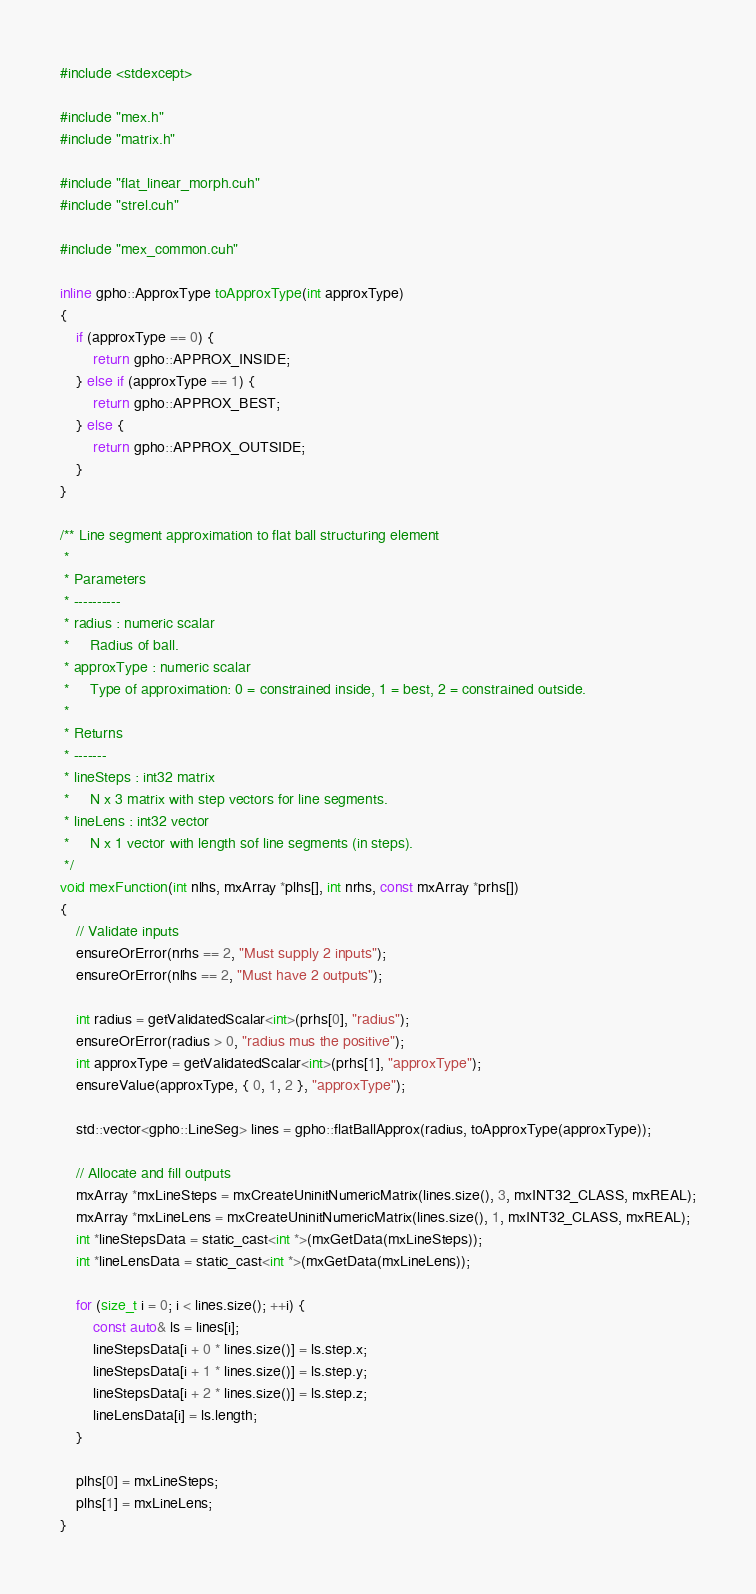<code> <loc_0><loc_0><loc_500><loc_500><_Cuda_>#include <stdexcept>

#include "mex.h"
#include "matrix.h"

#include "flat_linear_morph.cuh"
#include "strel.cuh"

#include "mex_common.cuh"

inline gpho::ApproxType toApproxType(int approxType)
{
    if (approxType == 0) {
        return gpho::APPROX_INSIDE;
    } else if (approxType == 1) {
        return gpho::APPROX_BEST;
    } else {
        return gpho::APPROX_OUTSIDE;
    }
}

/** Line segment approximation to flat ball structuring element
 *
 * Parameters
 * ----------
 * radius : numeric scalar
 *     Radius of ball.
 * approxType : numeric scalar
 *     Type of approximation: 0 = constrained inside, 1 = best, 2 = constrained outside.
 *
 * Returns
 * -------
 * lineSteps : int32 matrix
 *     N x 3 matrix with step vectors for line segments.
 * lineLens : int32 vector
 *     N x 1 vector with length sof line segments (in steps).
 */
void mexFunction(int nlhs, mxArray *plhs[], int nrhs, const mxArray *prhs[])
{
    // Validate inputs
    ensureOrError(nrhs == 2, "Must supply 2 inputs");
    ensureOrError(nlhs == 2, "Must have 2 outputs");

    int radius = getValidatedScalar<int>(prhs[0], "radius");
    ensureOrError(radius > 0, "radius mus the positive");
    int approxType = getValidatedScalar<int>(prhs[1], "approxType");
    ensureValue(approxType, { 0, 1, 2 }, "approxType");

    std::vector<gpho::LineSeg> lines = gpho::flatBallApprox(radius, toApproxType(approxType));

    // Allocate and fill outputs
    mxArray *mxLineSteps = mxCreateUninitNumericMatrix(lines.size(), 3, mxINT32_CLASS, mxREAL);
    mxArray *mxLineLens = mxCreateUninitNumericMatrix(lines.size(), 1, mxINT32_CLASS, mxREAL);
    int *lineStepsData = static_cast<int *>(mxGetData(mxLineSteps));
    int *lineLensData = static_cast<int *>(mxGetData(mxLineLens));

    for (size_t i = 0; i < lines.size(); ++i) {
        const auto& ls = lines[i];
        lineStepsData[i + 0 * lines.size()] = ls.step.x;
        lineStepsData[i + 1 * lines.size()] = ls.step.y;
        lineStepsData[i + 2 * lines.size()] = ls.step.z;
        lineLensData[i] = ls.length;
    }

    plhs[0] = mxLineSteps;
    plhs[1] = mxLineLens;
}</code> 